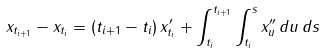<formula> <loc_0><loc_0><loc_500><loc_500>x _ { t _ { i + 1 } } - x _ { t _ { i } } = ( t _ { i + 1 } - t _ { i } ) \, x ^ { \prime } _ { t _ { i } } + \int _ { t _ { i } } ^ { t _ { i + 1 } } \int _ { t _ { i } } ^ { s } x ^ { \prime \prime } _ { u } \, d u \, d s</formula> 